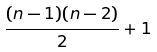<formula> <loc_0><loc_0><loc_500><loc_500>\frac { ( n - 1 ) ( n - 2 ) } { 2 } + 1</formula> 